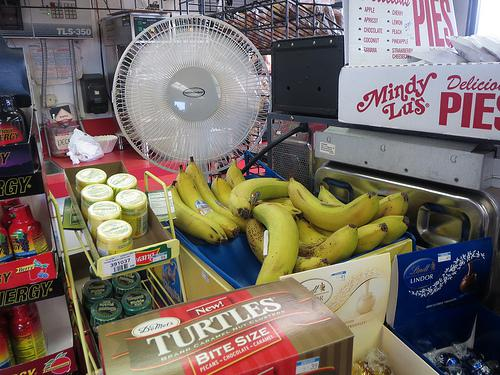Question: what fruit is being sold?
Choices:
A. Mangos.
B. Nectarines.
C. Bananas.
D. Peaches.
Answer with the letter. Answer: C Question: where is the Five Hour Energy?
Choices:
A. On a display.
B. In a man's right hand.
C. Sitting on a bench.
D. In a garbage bag.
Answer with the letter. Answer: A Question: who makes the pies?
Choices:
A. Mindy Lu's Delicious Pies.
B. A baker.
C. A machine.
D. Restaurant staff.
Answer with the letter. Answer: A 